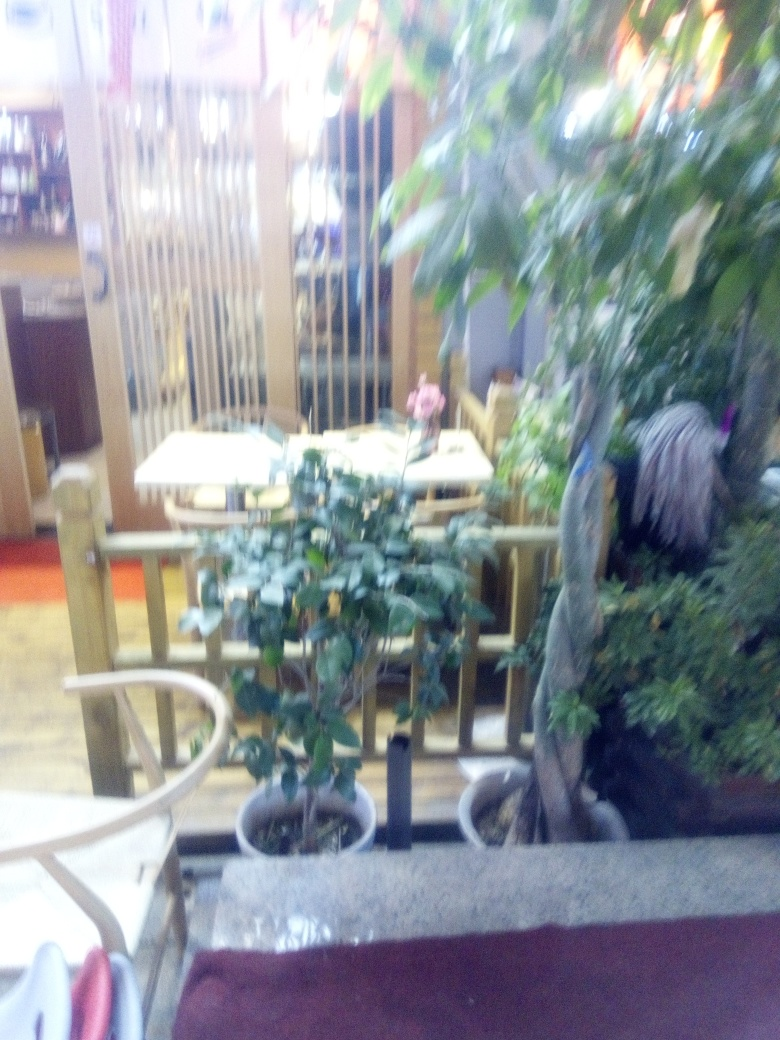What kind of setting is depicted in this image? The image depicts an indoor setting, likely a restaurant or cafe, with tables and chairs arranged for dining, and plants adding to the ambiance. 